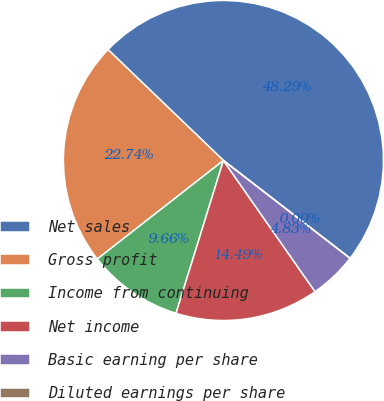Convert chart. <chart><loc_0><loc_0><loc_500><loc_500><pie_chart><fcel>Net sales<fcel>Gross profit<fcel>Income from continuing<fcel>Net income<fcel>Basic earning per share<fcel>Diluted earnings per share<nl><fcel>48.29%<fcel>22.74%<fcel>9.66%<fcel>14.49%<fcel>4.83%<fcel>0.0%<nl></chart> 